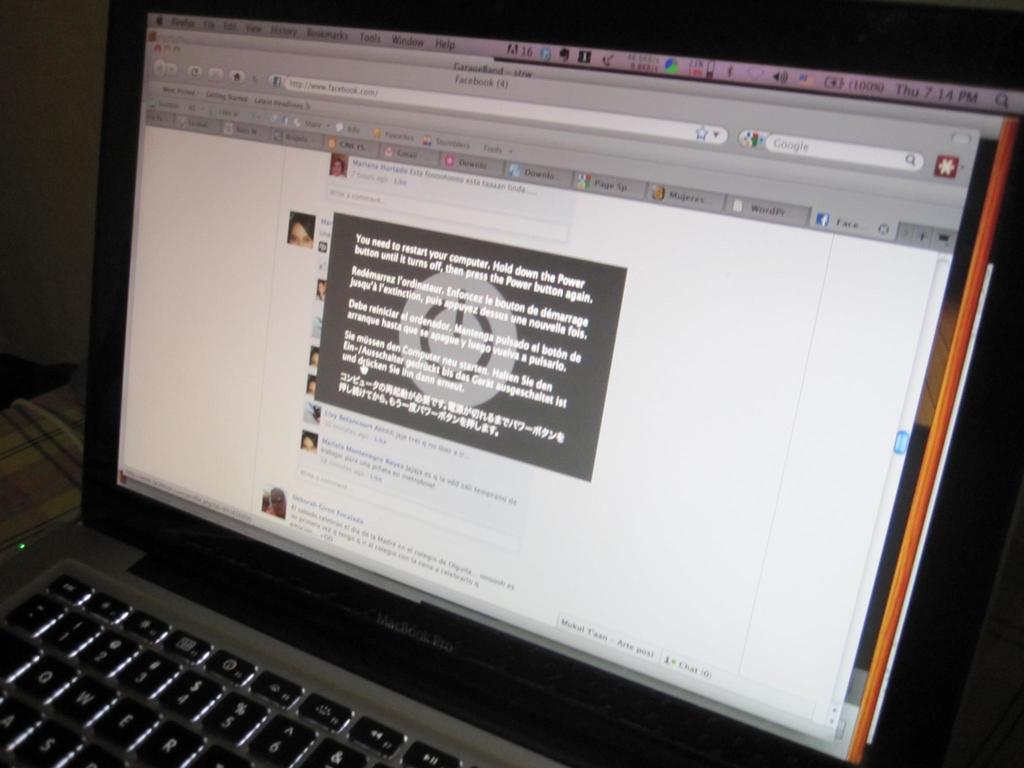What is the brand of this laptop?
Your answer should be very brief. Macbook pro. What serach bar is on the top right?
Provide a succinct answer. Google. 